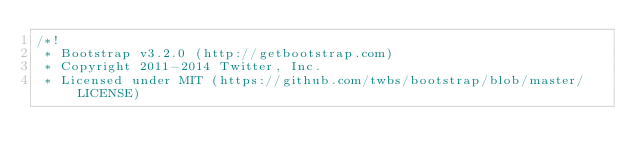<code> <loc_0><loc_0><loc_500><loc_500><_CSS_>/*!
 * Bootstrap v3.2.0 (http://getbootstrap.com)
 * Copyright 2011-2014 Twitter, Inc.
 * Licensed under MIT (https://github.com/twbs/bootstrap/blob/master/LICENSE)</code> 